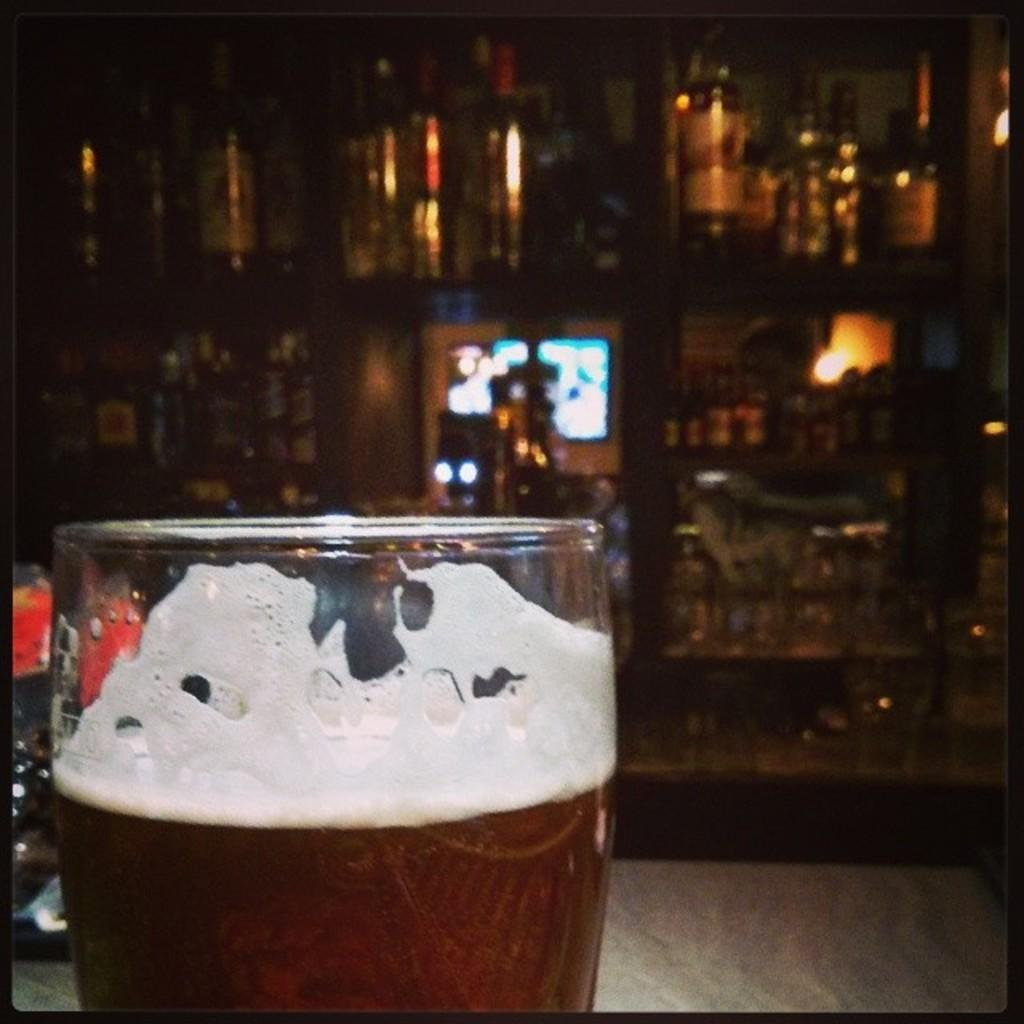What is located in the bottom left side of the image? There is a glass in the bottom left side of the image. What can be seen in the middle of the image? There are objects on a shelf in the middle of the image. Is there any grass visible in the image? No, there is no grass present in the image. What type of frame surrounds the objects on the shelf? There is no frame surrounding the objects on the shelf in the image. 